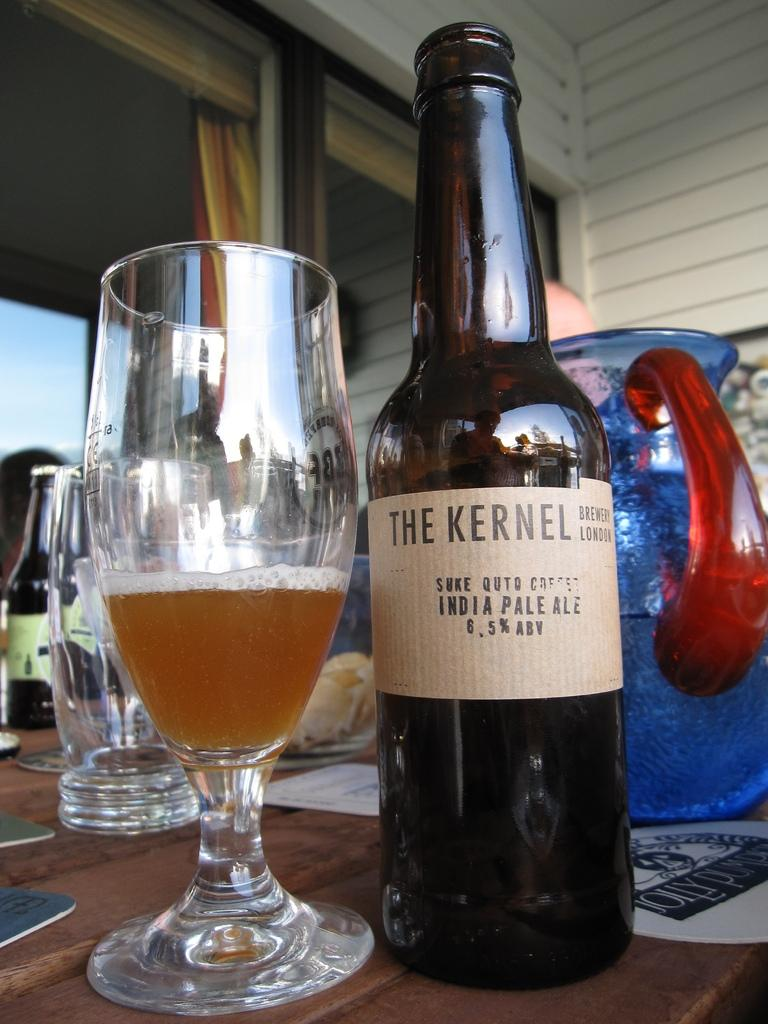<image>
Offer a succinct explanation of the picture presented. A bottle of The Kernel Indian pale ale 